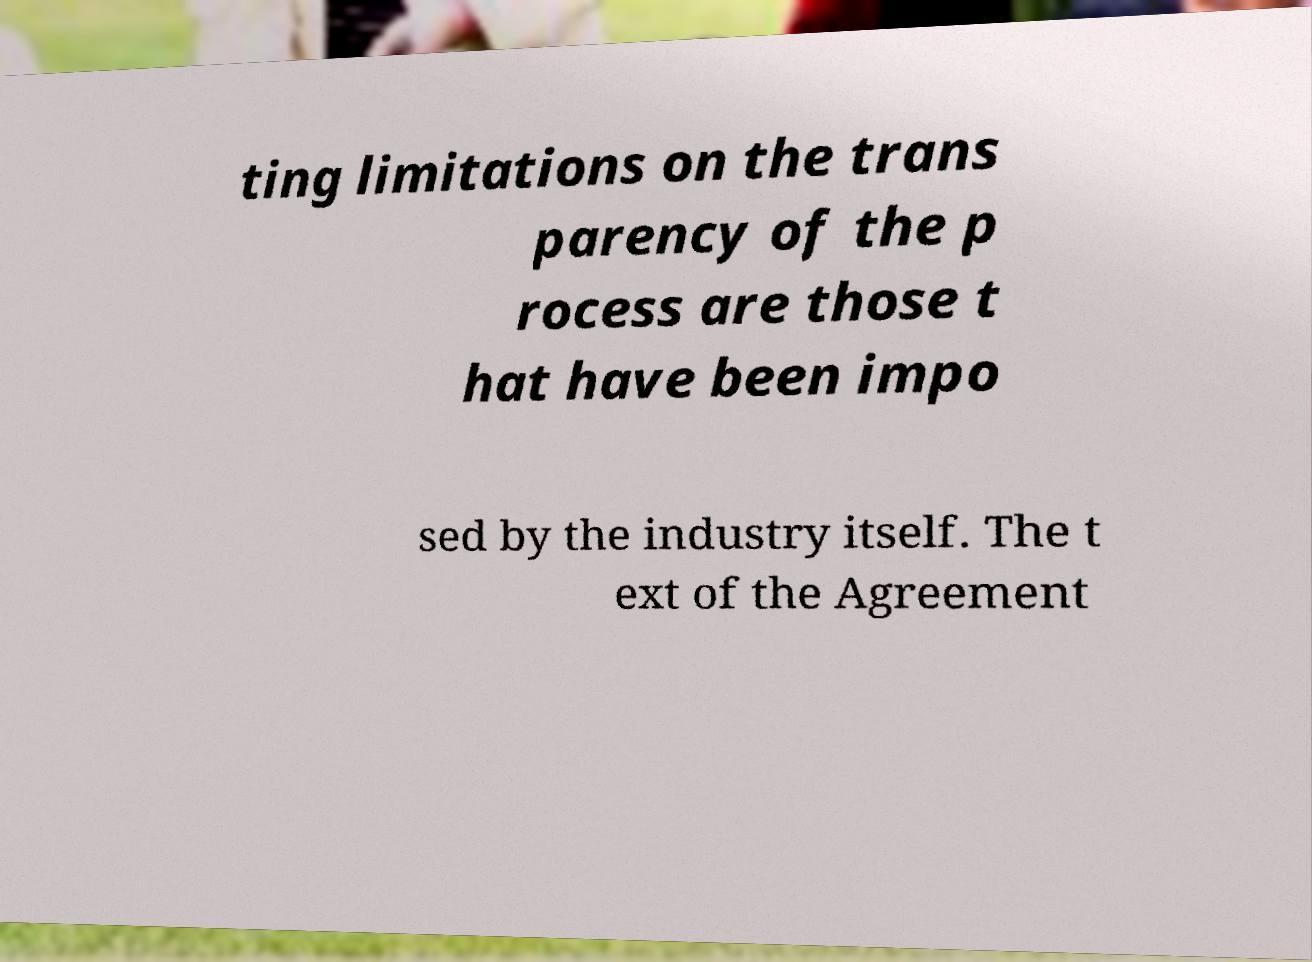Could you extract and type out the text from this image? ting limitations on the trans parency of the p rocess are those t hat have been impo sed by the industry itself. The t ext of the Agreement 